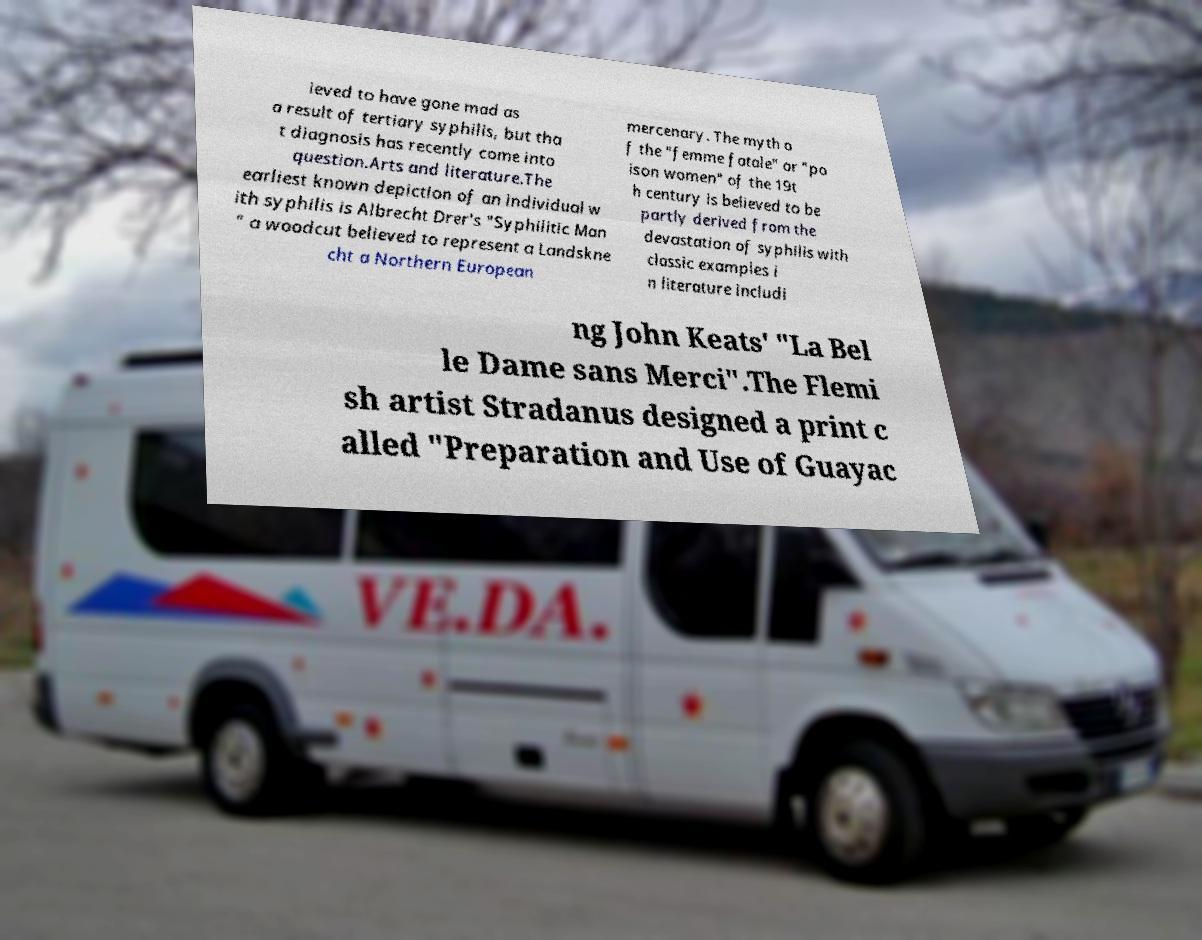What messages or text are displayed in this image? I need them in a readable, typed format. ieved to have gone mad as a result of tertiary syphilis, but tha t diagnosis has recently come into question.Arts and literature.The earliest known depiction of an individual w ith syphilis is Albrecht Drer's "Syphilitic Man " a woodcut believed to represent a Landskne cht a Northern European mercenary. The myth o f the "femme fatale" or "po ison women" of the 19t h century is believed to be partly derived from the devastation of syphilis with classic examples i n literature includi ng John Keats' "La Bel le Dame sans Merci".The Flemi sh artist Stradanus designed a print c alled "Preparation and Use of Guayac 